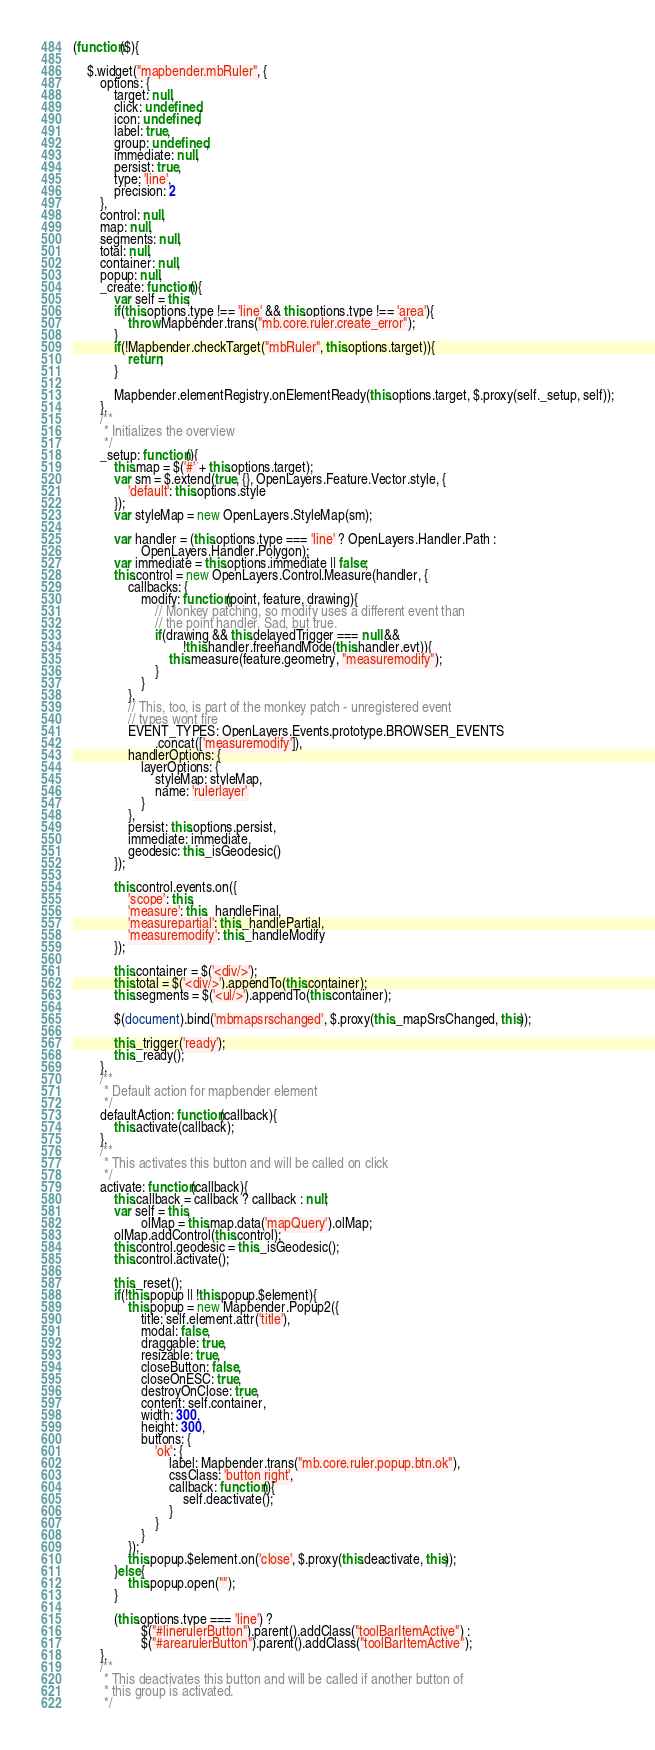<code> <loc_0><loc_0><loc_500><loc_500><_JavaScript_>(function($){

    $.widget("mapbender.mbRuler", {
        options: {
            target: null,
            click: undefined,
            icon: undefined,
            label: true,
            group: undefined,
            immediate: null,
            persist: true,
            type: 'line',
            precision: 2
        },
        control: null,
        map: null,
        segments: null,
        total: null,
        container: null,
        popup: null,
        _create: function(){
            var self = this;
            if(this.options.type !== 'line' && this.options.type !== 'area'){
                throw Mapbender.trans("mb.core.ruler.create_error");
            }
            if(!Mapbender.checkTarget("mbRuler", this.options.target)){
                return;
            }

            Mapbender.elementRegistry.onElementReady(this.options.target, $.proxy(self._setup, self));
        },
        /**
         * Initializes the overview
         */
        _setup: function(){
            this.map = $('#' + this.options.target);
            var sm = $.extend(true, {}, OpenLayers.Feature.Vector.style, {
                'default': this.options.style
            });
            var styleMap = new OpenLayers.StyleMap(sm);

            var handler = (this.options.type === 'line' ? OpenLayers.Handler.Path :
                    OpenLayers.Handler.Polygon);
            var immediate = this.options.immediate || false;
            this.control = new OpenLayers.Control.Measure(handler, {
                callbacks: {
                    modify: function(point, feature, drawing){
                        // Monkey patching, so modify uses a different event than
                        // the point handler. Sad, but true.
                        if(drawing && this.delayedTrigger === null &&
                                !this.handler.freehandMode(this.handler.evt)){
                            this.measure(feature.geometry, "measuremodify");
                        }
                    }
                },
                // This, too, is part of the monkey patch - unregistered event
                // types wont fire
                EVENT_TYPES: OpenLayers.Events.prototype.BROWSER_EVENTS
                        .concat(['measuremodify']),
                handlerOptions: {
                    layerOptions: {
                        styleMap: styleMap,
                        name: 'rulerlayer'
                    }
                },
                persist: this.options.persist,
                immediate: immediate,
                geodesic: this._isGeodesic()
            });

            this.control.events.on({
                'scope': this,
                'measure': this._handleFinal,
                'measurepartial': this._handlePartial,
                'measuremodify': this._handleModify
            });

            this.container = $('<div/>');
            this.total = $('<div/>').appendTo(this.container);
            this.segments = $('<ul/>').appendTo(this.container);

            $(document).bind('mbmapsrschanged', $.proxy(this._mapSrsChanged, this));
            
            this._trigger('ready');
            this._ready();
        },
        /**
         * Default action for mapbender element
         */
        defaultAction: function(callback){
            this.activate(callback);
        },
        /**
         * This activates this button and will be called on click
         */
        activate: function(callback){
            this.callback = callback ? callback : null;
            var self = this,
                    olMap = this.map.data('mapQuery').olMap;
            olMap.addControl(this.control);
            this.control.geodesic = this._isGeodesic();
            this.control.activate();

            this._reset();
            if(!this.popup || !this.popup.$element){
                this.popup = new Mapbender.Popup2({
                    title: self.element.attr('title'),
                    modal: false,
                    draggable: true,
                    resizable: true,
                    closeButton: false,
                    closeOnESC: true,
                    destroyOnClose: true,
                    content: self.container,
                    width: 300,
                    height: 300,
                    buttons: {
                        'ok': {
                            label: Mapbender.trans("mb.core.ruler.popup.btn.ok"),
                            cssClass: 'button right',
                            callback: function(){
                                self.deactivate();
                            }
                        }
                    }
                });
                this.popup.$element.on('close', $.proxy(this.deactivate, this));
            }else{
                this.popup.open("");
            }

            (this.options.type === 'line') ?
                    $("#linerulerButton").parent().addClass("toolBarItemActive") :
                    $("#arearulerButton").parent().addClass("toolBarItemActive");
        },
        /**
         * This deactivates this button and will be called if another button of
         * this group is activated.
         */</code> 